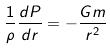Convert formula to latex. <formula><loc_0><loc_0><loc_500><loc_500>\frac { 1 } { \rho } \frac { d P } { d r } = - \frac { G m } { r ^ { 2 } }</formula> 